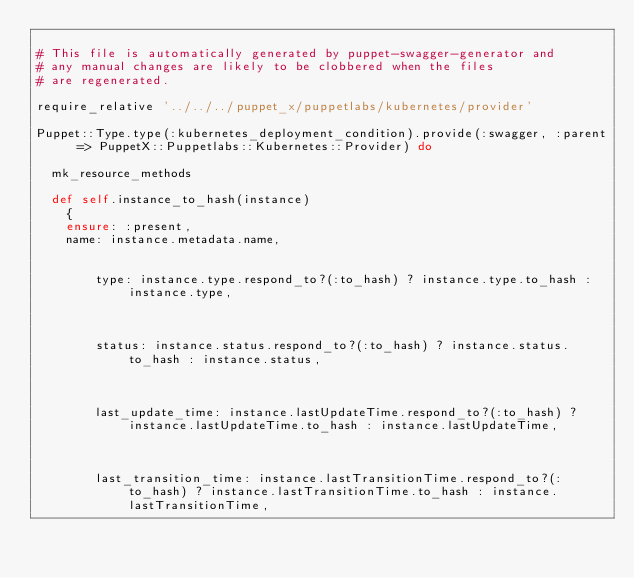Convert code to text. <code><loc_0><loc_0><loc_500><loc_500><_Ruby_>
# This file is automatically generated by puppet-swagger-generator and
# any manual changes are likely to be clobbered when the files
# are regenerated.

require_relative '../../../puppet_x/puppetlabs/kubernetes/provider'

Puppet::Type.type(:kubernetes_deployment_condition).provide(:swagger, :parent => PuppetX::Puppetlabs::Kubernetes::Provider) do

  mk_resource_methods

  def self.instance_to_hash(instance)
    {
    ensure: :present,
    name: instance.metadata.name,
    
      
        type: instance.type.respond_to?(:to_hash) ? instance.type.to_hash : instance.type,
      
    
      
        status: instance.status.respond_to?(:to_hash) ? instance.status.to_hash : instance.status,
      
    
      
        last_update_time: instance.lastUpdateTime.respond_to?(:to_hash) ? instance.lastUpdateTime.to_hash : instance.lastUpdateTime,
      
    
      
        last_transition_time: instance.lastTransitionTime.respond_to?(:to_hash) ? instance.lastTransitionTime.to_hash : instance.lastTransitionTime,
      
    
      </code> 